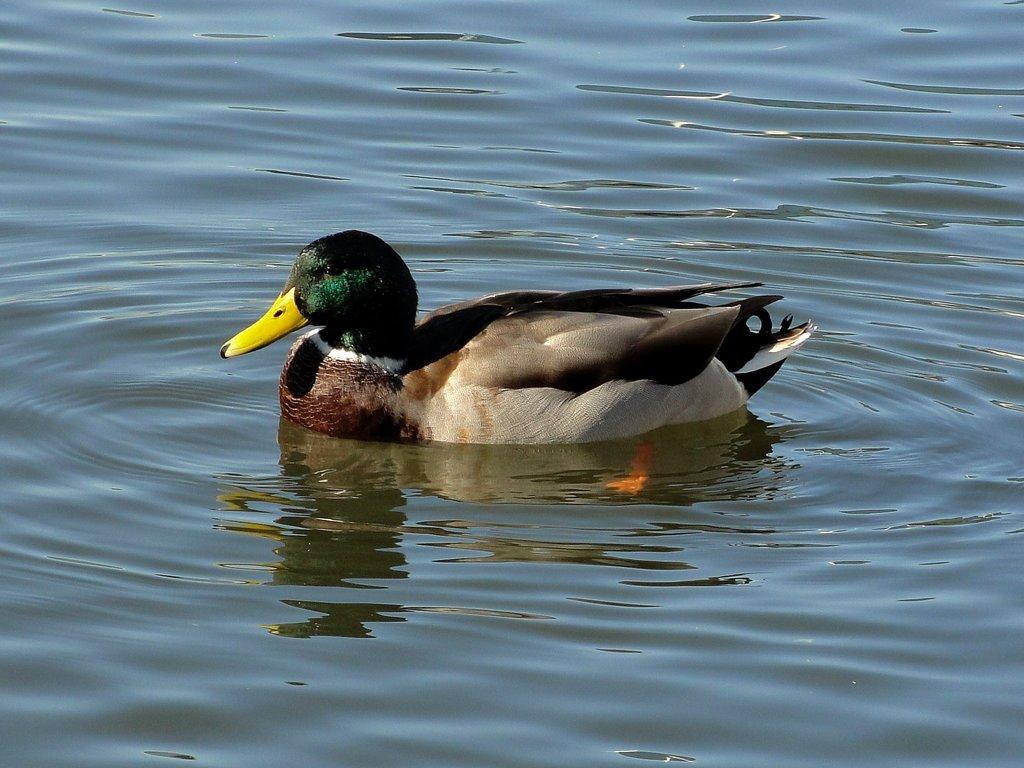What body of water is present in the image? There is a pond in the image. What type of animal can be seen in the pond? There is a duck in the pond. Can you see a person rubbing the duck's back in the image? There is no person present in the image, and therefore no one is rubbing the duck's back. Are there any squirrels visible in the image? There are no squirrels present in the image; it features a pond with a duck. 